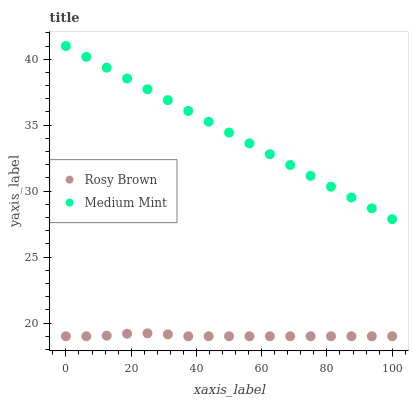Does Rosy Brown have the minimum area under the curve?
Answer yes or no. Yes. Does Medium Mint have the maximum area under the curve?
Answer yes or no. Yes. Does Rosy Brown have the maximum area under the curve?
Answer yes or no. No. Is Medium Mint the smoothest?
Answer yes or no. Yes. Is Rosy Brown the roughest?
Answer yes or no. Yes. Is Rosy Brown the smoothest?
Answer yes or no. No. Does Rosy Brown have the lowest value?
Answer yes or no. Yes. Does Medium Mint have the highest value?
Answer yes or no. Yes. Does Rosy Brown have the highest value?
Answer yes or no. No. Is Rosy Brown less than Medium Mint?
Answer yes or no. Yes. Is Medium Mint greater than Rosy Brown?
Answer yes or no. Yes. Does Rosy Brown intersect Medium Mint?
Answer yes or no. No. 